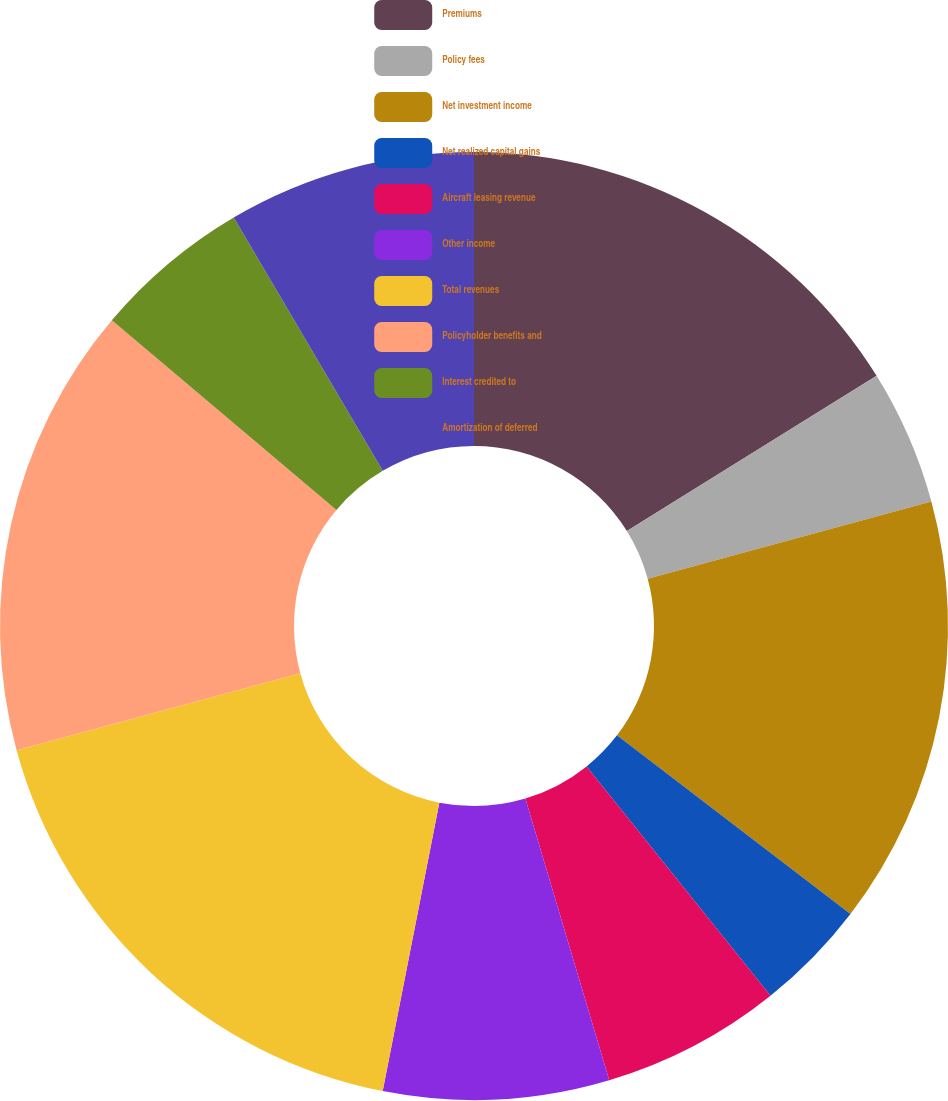<chart> <loc_0><loc_0><loc_500><loc_500><pie_chart><fcel>Premiums<fcel>Policy fees<fcel>Net investment income<fcel>Net realized capital gains<fcel>Aircraft leasing revenue<fcel>Other income<fcel>Total revenues<fcel>Policyholder benefits and<fcel>Interest credited to<fcel>Amortization of deferred<nl><fcel>16.15%<fcel>4.62%<fcel>14.62%<fcel>3.85%<fcel>6.15%<fcel>7.69%<fcel>17.69%<fcel>15.38%<fcel>5.38%<fcel>8.46%<nl></chart> 